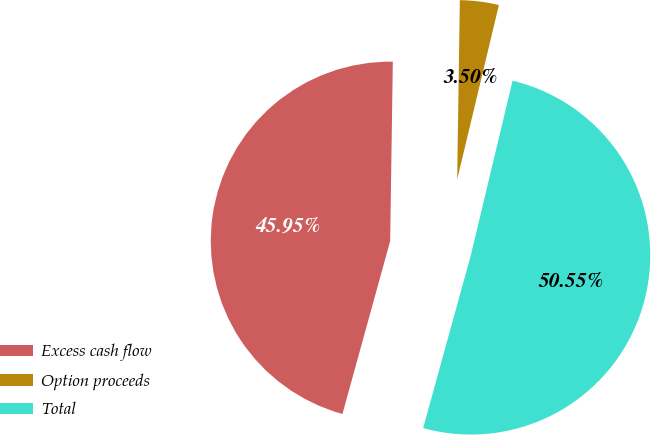<chart> <loc_0><loc_0><loc_500><loc_500><pie_chart><fcel>Excess cash flow<fcel>Option proceeds<fcel>Total<nl><fcel>45.95%<fcel>3.5%<fcel>50.55%<nl></chart> 